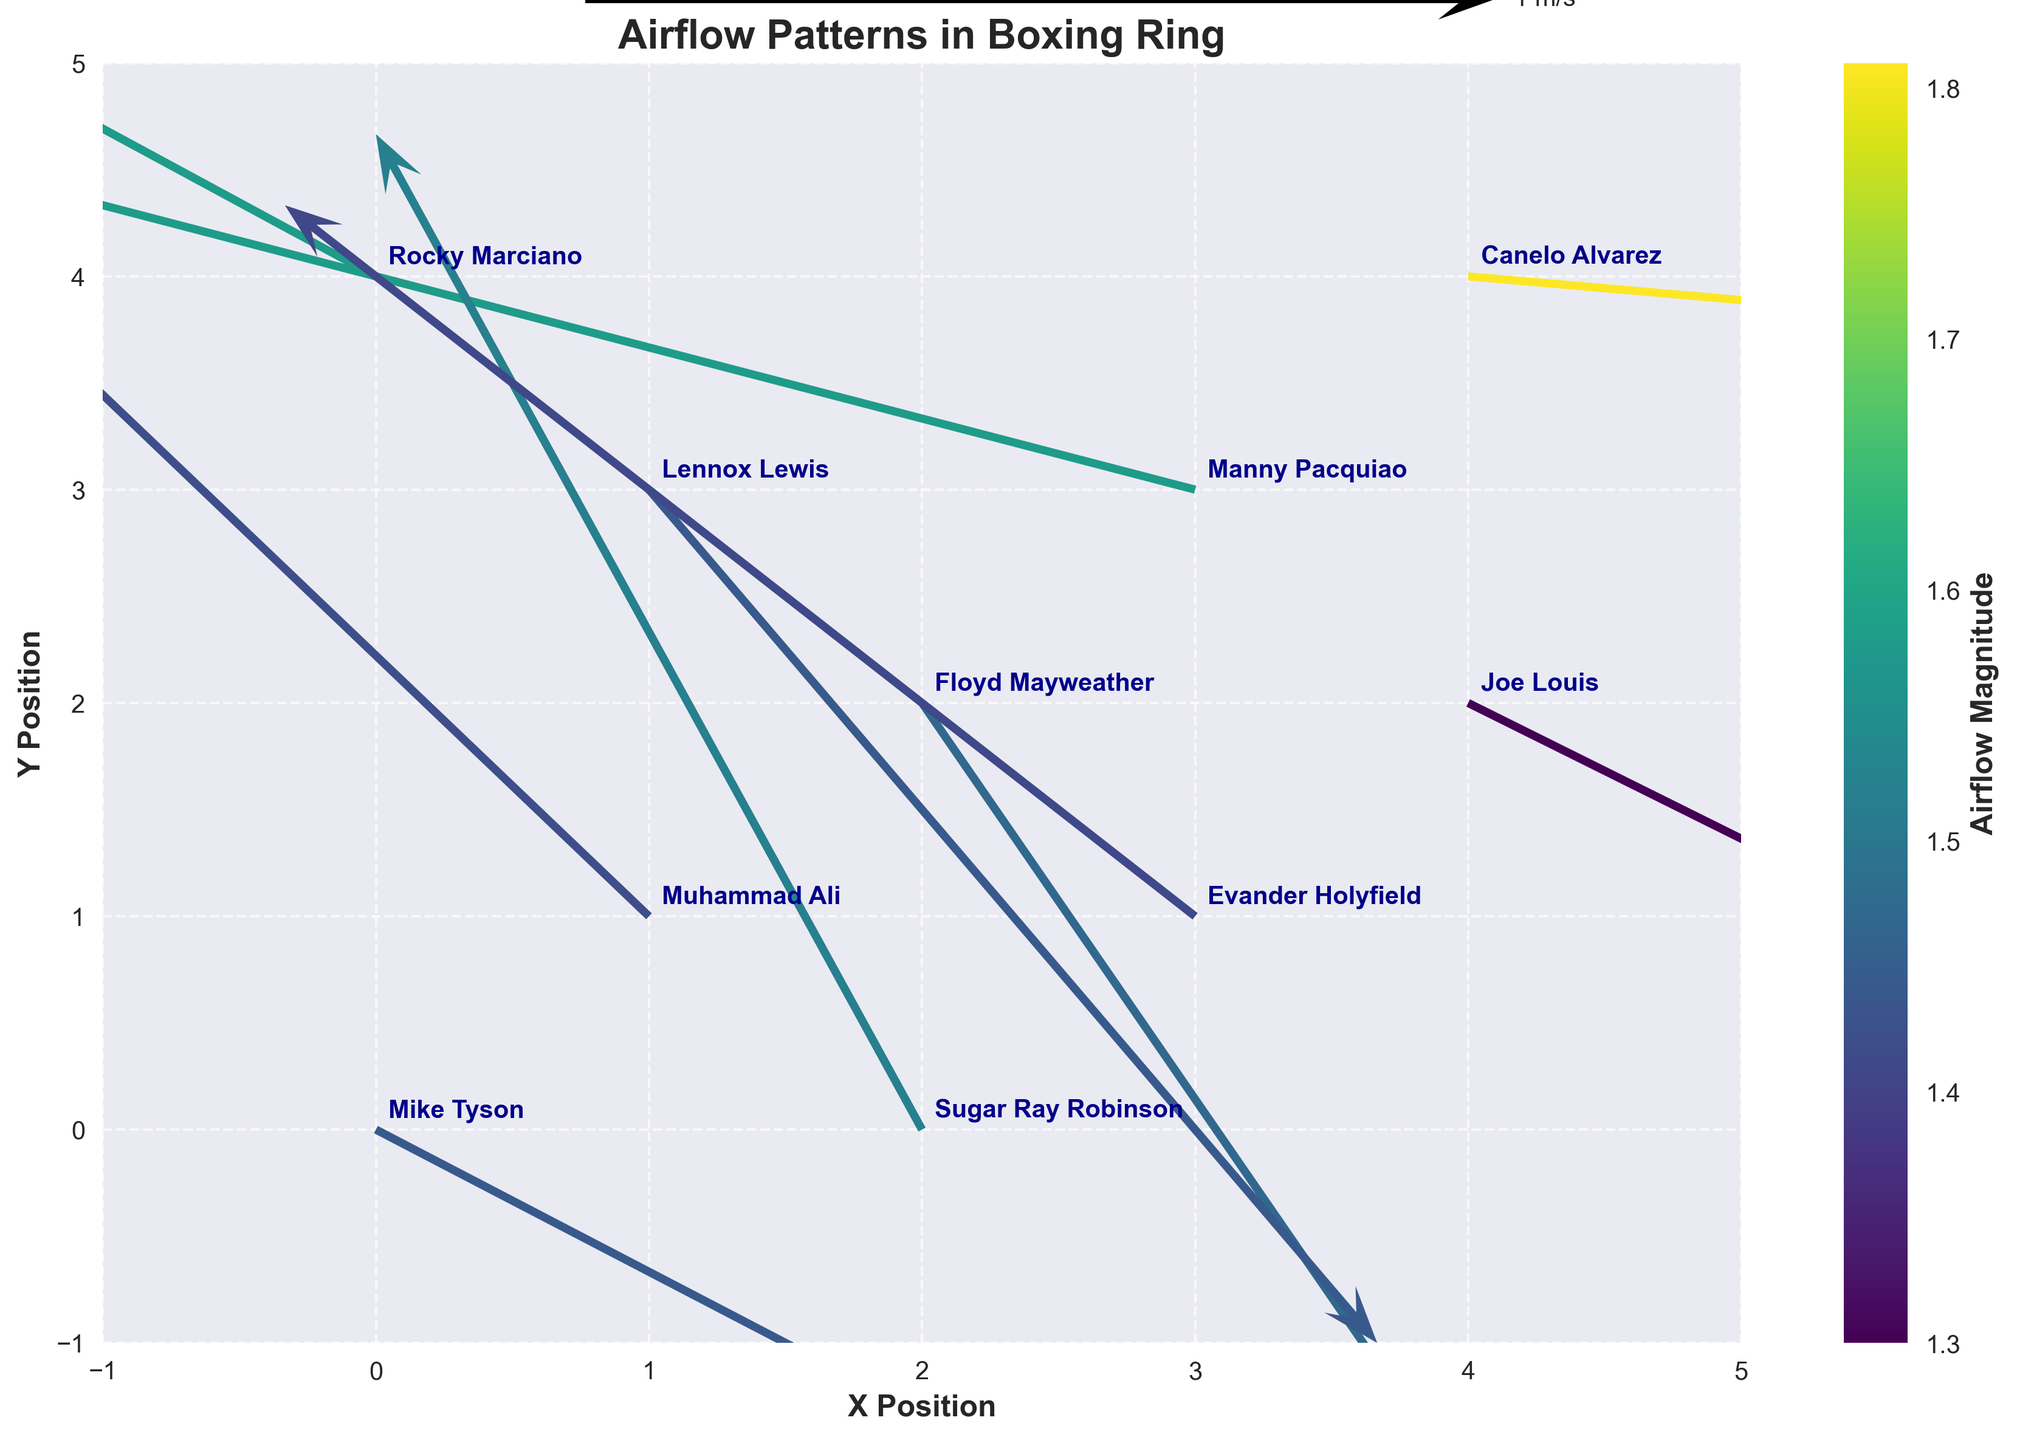What is the title of the figure? The title is usually displayed at the top of the figure. In this case, it reads "Airflow Patterns in Boxing Ring".
Answer: Airflow Patterns in Boxing Ring Which wind arrow represents the fighter with the highest airflow magnitude? By looking at the color gradient used to represent the magnitude, the arrow corresponding to the highest magnitude will be the darkest or most vivid in color. In this plot, the arrow representing Canelo Alvarez at the coordinates (4, 4) has the highest magnitude value of 1.81.
Answer: Canelo Alvarez Who is the fighter positioned at coordinates (1, 3)? The fighter names are annotated directly on the plot next to their coordinates. At coordinates (1, 3), the annotated fighter's name is Lennox Lewis.
Answer: Lennox Lewis What is the average magnitude of the airflow produced by Floyd Mayweather and Sugar Ray Robinson? First, identify the magnitudes for Floyd Mayweather and Sugar Ray Robinson, which are 1.47 and 1.52 respectively. Calculate the average by adding the two magnitudes and dividing by 2: (1.47 + 1.52) / 2 = 1.495.
Answer: 1.495 Compare the airflow vector directions between Muhammad Ali and Evander Holyfield. How do they differ? Muhammad Ali's vector points up and to the right (north-east), while Evander Holyfield's vector points up and to the left (north-west). The visual inspection of the plot to compare the direction of both fighters' airflow vectors indicates they are pointing in opposite directions.
Answer: Opposite directions Which two fighters have the same airflow magnitude, and what is that magnitude? By examining the color scale and the numerical magnitude values, we find that Rocky Marciano and Manny Pacquiao both have an airflow magnitude of 1.58.
Answer: Rocky Marciano and Manny Pacquiao; 1.58 Among the fighters at positions (2, 2) and (3, 3), who has the stronger airflow magnitude? Identify the magnitudes for Floyd Mayweather at (2, 2) and Manny Pacquiao at (3, 3) which are 1.47 and 1.58 respectively. Since 1.58 is greater than 1.47, Manny Pacquiao has the stronger airflow magnitude.
Answer: Manny Pacquiao What direction does the vector for Joe Louis point? The direction can be deduced by the components (u, v). Joe Louis at (4, 2) has components (1.1, -0.7), which means his airflow vector points to the right (positive x) and down (negative y), or south-east.
Answer: South-east How many fighters produce an airflow magnitude greater than 1.5? Based on the magnitudes given, the fighters with magnitudes greater than 1.5 are those with magnitudes of 1.52, 1.58, and 1.81, totaling up to four fighters (Sugar Ray Robinson, Rocky Marciano, Manny Pacquiao, and Canelo Alvarez).
Answer: Four For the fighter at coordinates (2, 0), what is the direction of the airflow vector? The components for the vector at (2, 0), which is Sugar Ray Robinson, are (-0.6, 1.4). This implies a direction that is to the left (negative x) and upwards (positive y), or north-west.
Answer: North-west 